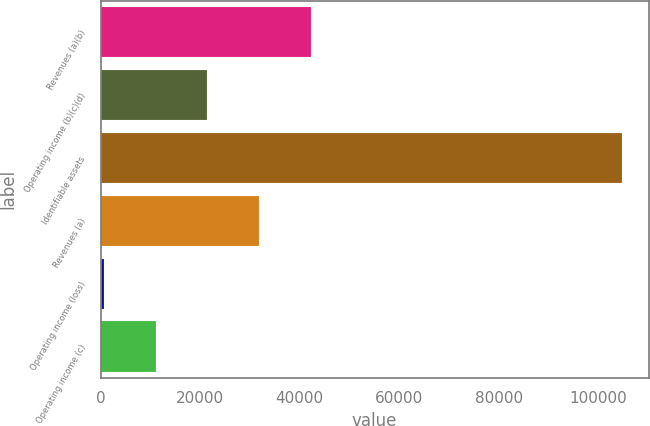Convert chart. <chart><loc_0><loc_0><loc_500><loc_500><bar_chart><fcel>Revenues (a)(b)<fcel>Operating income (b)(c)(d)<fcel>Identifiable assets<fcel>Revenues (a)<fcel>Operating income (loss)<fcel>Operating income (c)<nl><fcel>42334<fcel>21490<fcel>104866<fcel>31912<fcel>646<fcel>11068<nl></chart> 